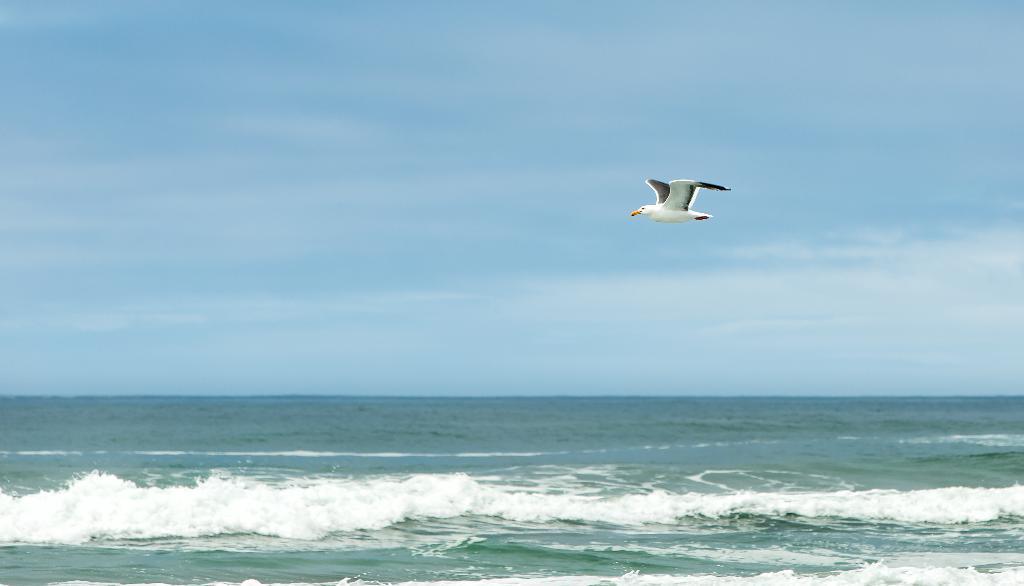Could you give a brief overview of what you see in this image? There is a white bird flying in the sky. There is water below it. 